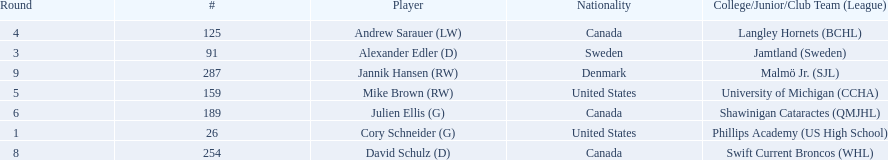Who are the players? Cory Schneider (G), Alexander Edler (D), Andrew Sarauer (LW), Mike Brown (RW), Julien Ellis (G), David Schulz (D), Jannik Hansen (RW). Of those, who is from denmark? Jannik Hansen (RW). 